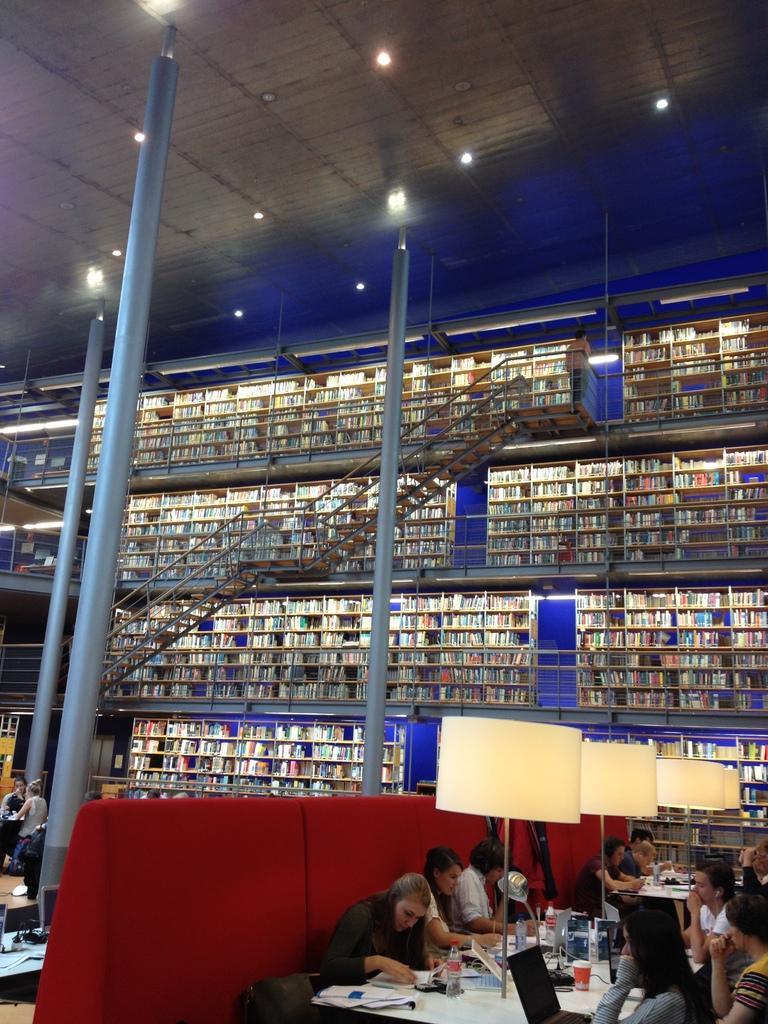Describe this image in one or two sentences. In this image I can see few persons sitting on chairs around the table. On the table I can see few bottles, few laptops, few cups and few other objects. I can see few huge pillars, few stairs, few persons, few racks with few objects in them, the ceiling and few lights to the ceiling. 